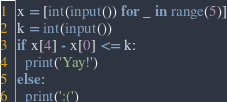Convert code to text. <code><loc_0><loc_0><loc_500><loc_500><_Python_>x = [int(input()) for _ in range(5)]
k = int(input())
if x[4] - x[0] <= k:
  print('Yay!')
else:
  print(':(')</code> 